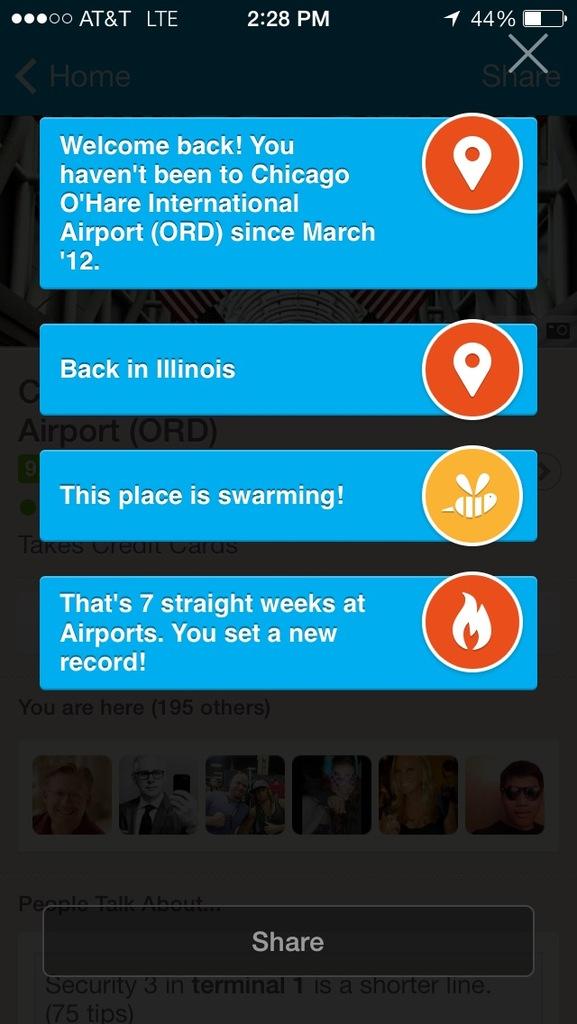What time does the phone show?
Your answer should be very brief. 2:28 pm. What is the big button at the bottom?
Your answer should be very brief. Share. 